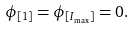<formula> <loc_0><loc_0><loc_500><loc_500>\phi _ { [ 1 ] } = \phi _ { [ I _ { \max } ] } = 0 .</formula> 